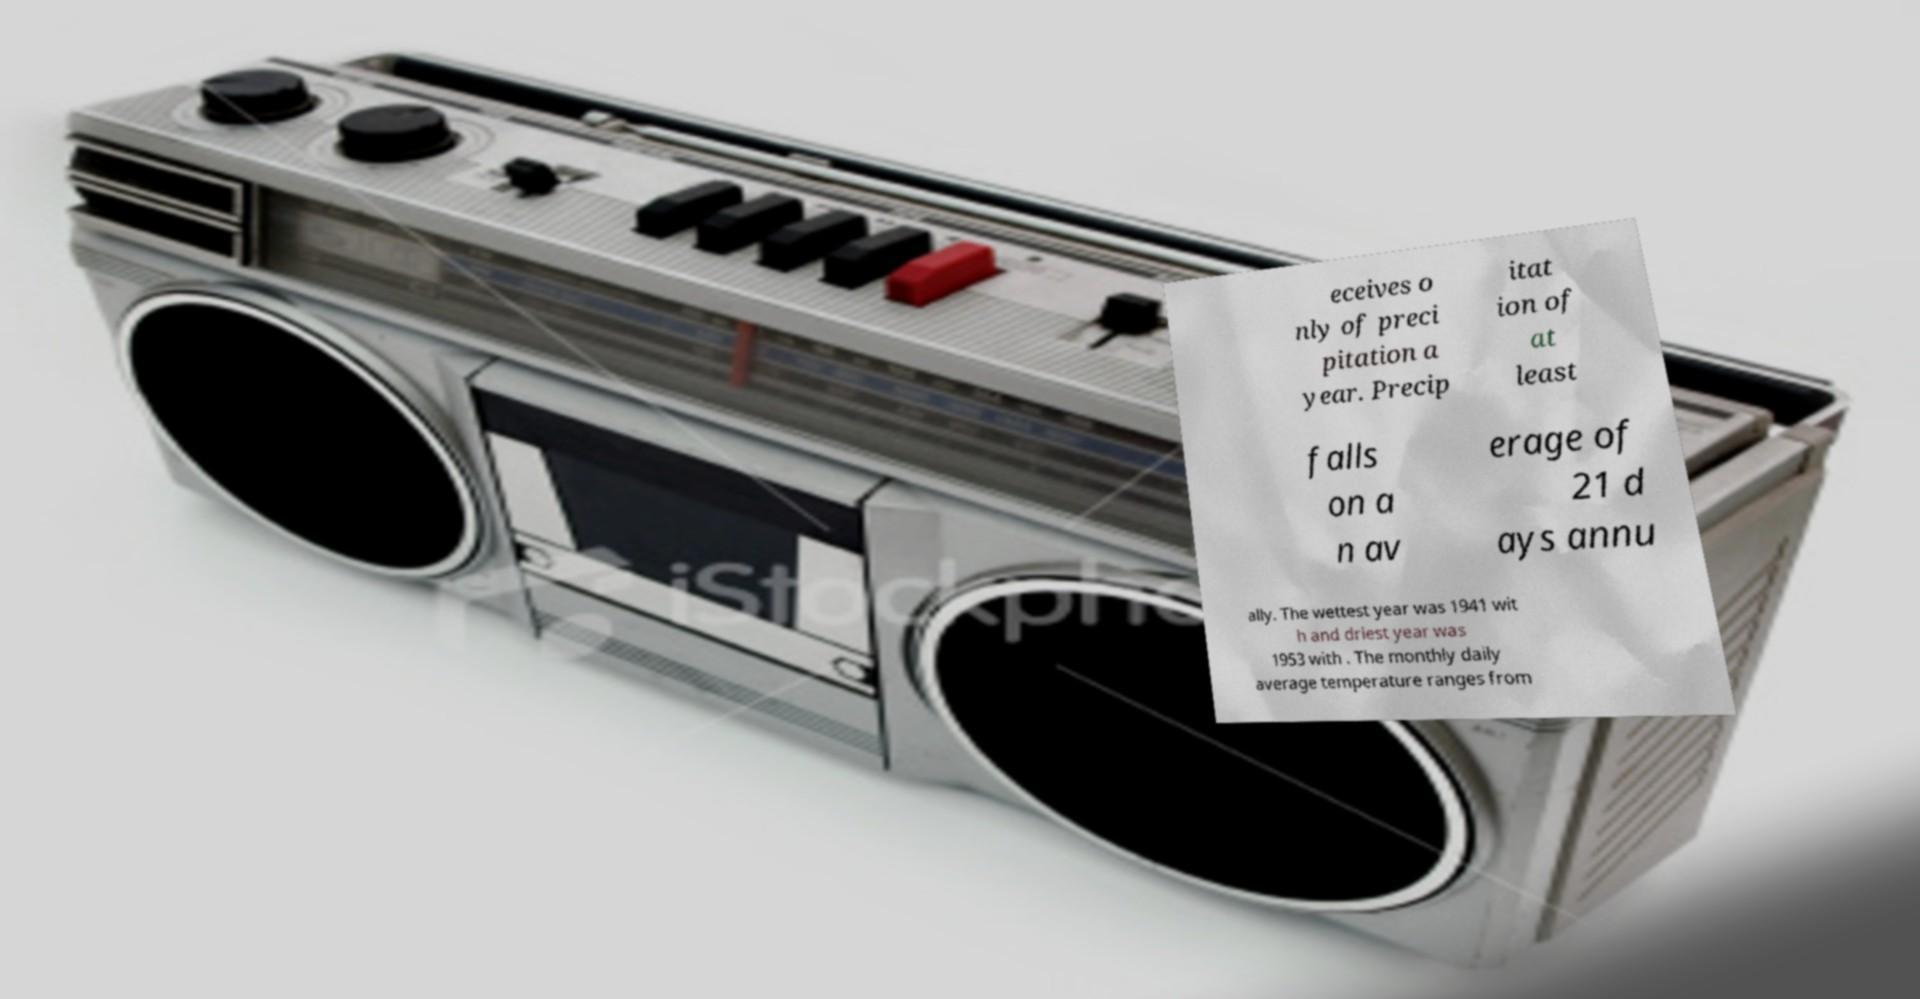Please identify and transcribe the text found in this image. eceives o nly of preci pitation a year. Precip itat ion of at least falls on a n av erage of 21 d ays annu ally. The wettest year was 1941 wit h and driest year was 1953 with . The monthly daily average temperature ranges from 